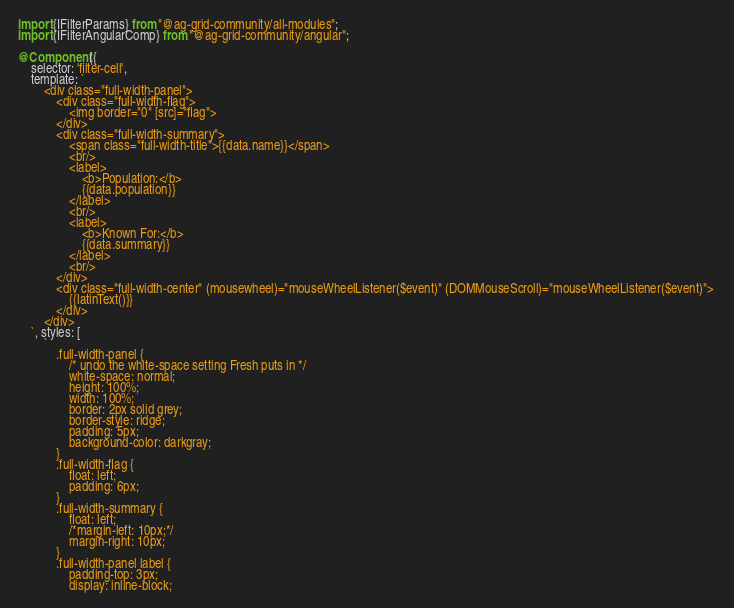<code> <loc_0><loc_0><loc_500><loc_500><_TypeScript_>import {IFilterParams} from "@ag-grid-community/all-modules";
import {IFilterAngularComp} from "@ag-grid-community/angular";

@Component({
    selector: 'filter-cell',
    template: `
        <div class="full-width-panel"> 
            <div class="full-width-flag"> 
                <img border="0" [src]="flag"> 
            </div> 
            <div class="full-width-summary"> 
                <span class="full-width-title">{{data.name}}</span>
                <br/>
                <label>
                    <b>Population:</b>
                    {{data.population}} 
                </label>
                <br/> 
                <label>
                    <b>Known For:</b>  
                    {{data.summary}} 
                </label>
                <br/> 
            </div> 
            <div class="full-width-center" (mousewheel)="mouseWheelListener($event)" (DOMMouseScroll)="mouseWheelListener($event)"> 
                {{latinText()}} 
            </div> 
        </div>
    `, styles: [
        `
            .full-width-panel {
                /* undo the white-space setting Fresh puts in */
                white-space: normal;
                height: 100%;
                width: 100%;
                border: 2px solid grey;
                border-style: ridge;
                padding: 5px;
                background-color: darkgray;
            }
            .full-width-flag {
                float: left;
                padding: 6px;
            }
            .full-width-summary {
                float: left;
                /*margin-left: 10px;*/
                margin-right: 10px;
            }
            .full-width-panel label {
                padding-top: 3px;
                display: inline-block;</code> 